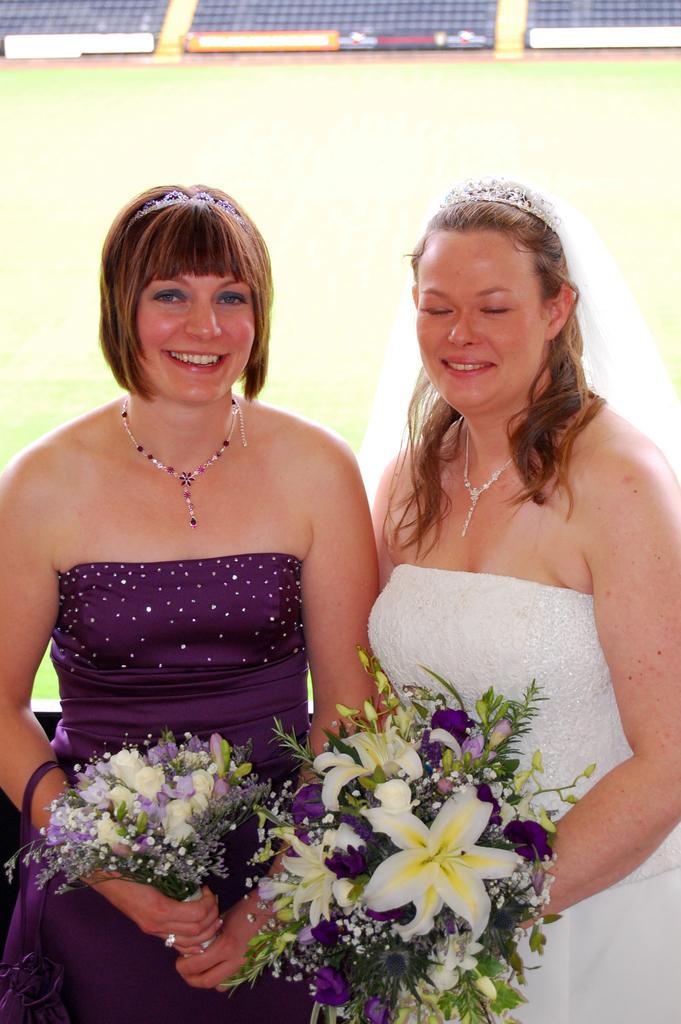Could you give a brief overview of what you see in this image? The woman in the right corner of the picture who is wearing a white dress is holding a flower bouquet in her hands. She is smiling. Beside her, we see the woman in the purple dress is also holding a flower bouquet in her hands. She is also smiling. Behind them, it is green in color. At the top of the picture, we see something in blue, orange and white color. This picture might be clicked in the outdoor stadium. 